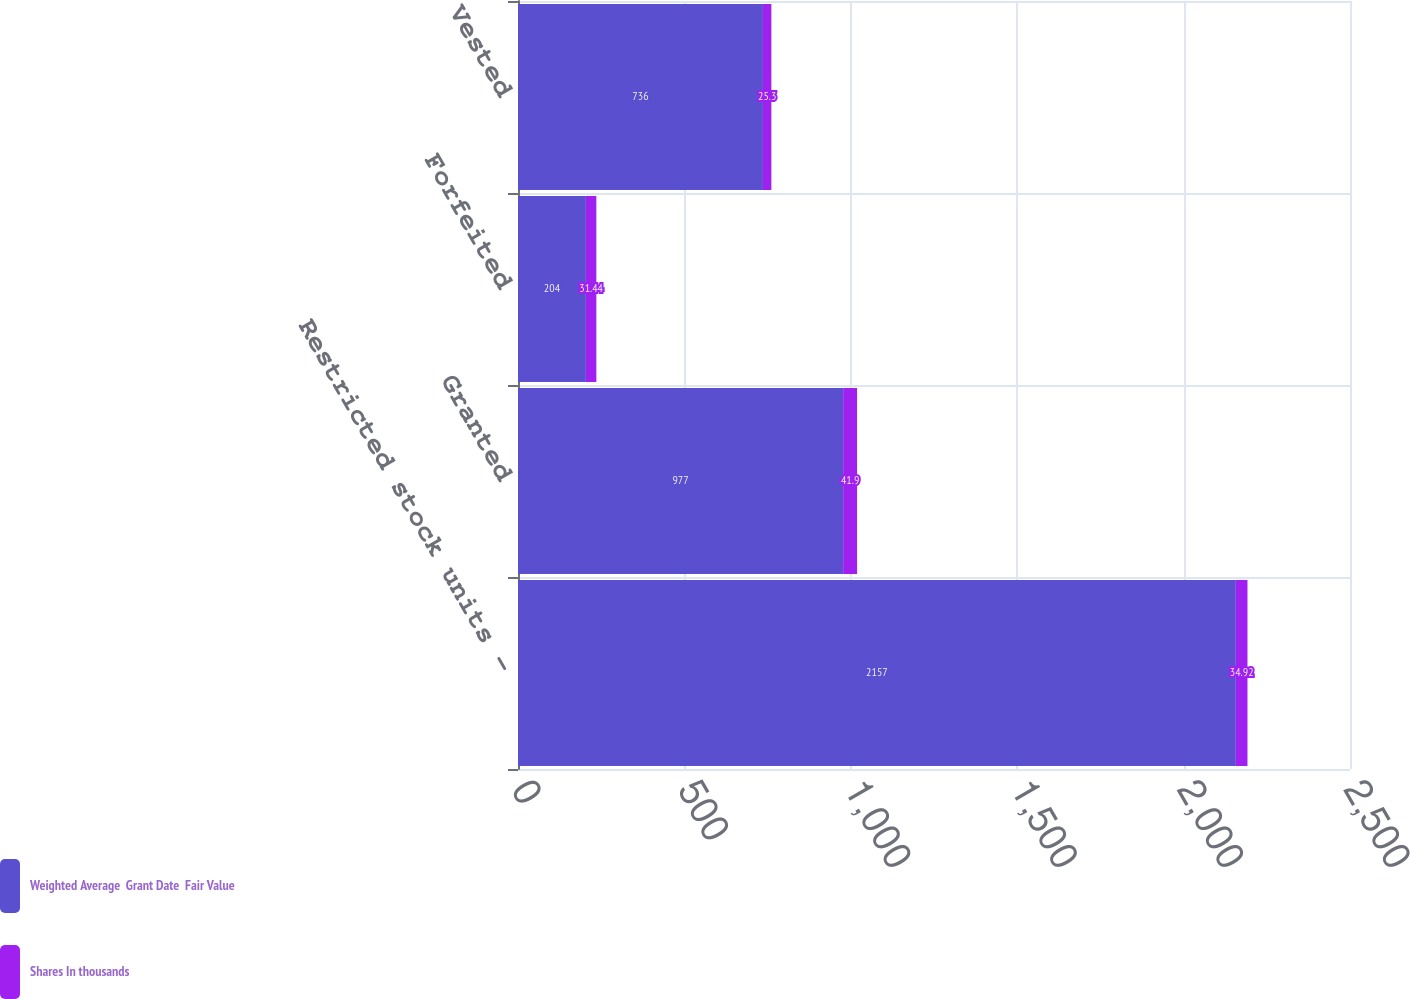Convert chart. <chart><loc_0><loc_0><loc_500><loc_500><stacked_bar_chart><ecel><fcel>Restricted stock units -<fcel>Granted<fcel>Forfeited<fcel>Vested<nl><fcel>Weighted Average  Grant Date  Fair Value<fcel>2157<fcel>977<fcel>204<fcel>736<nl><fcel>Shares In thousands<fcel>34.92<fcel>41.9<fcel>31.44<fcel>25.3<nl></chart> 